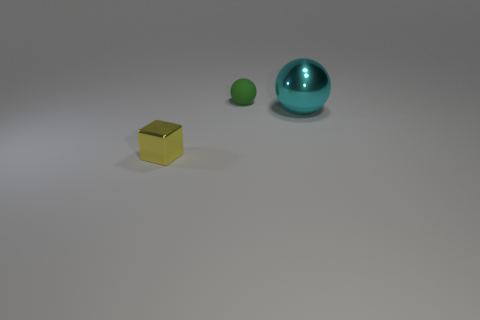Subtract all cubes. How many objects are left? 2 Subtract all cyan balls. How many balls are left? 1 Add 1 big gray shiny blocks. How many objects exist? 4 Subtract all yellow cylinders. How many yellow spheres are left? 0 Subtract all big spheres. Subtract all tiny rubber balls. How many objects are left? 1 Add 2 small green balls. How many small green balls are left? 3 Add 2 tiny objects. How many tiny objects exist? 4 Subtract 0 red blocks. How many objects are left? 3 Subtract 1 blocks. How many blocks are left? 0 Subtract all purple spheres. Subtract all cyan cubes. How many spheres are left? 2 